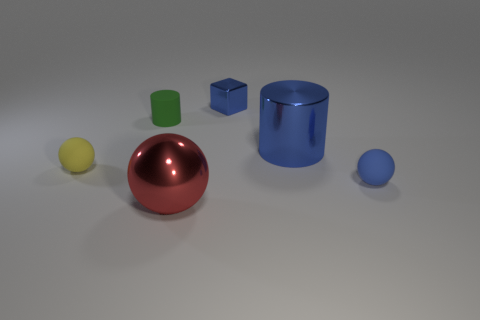Add 4 brown metal cylinders. How many objects exist? 10 Subtract all blocks. How many objects are left? 5 Add 5 small red rubber things. How many small red rubber things exist? 5 Subtract 0 cyan spheres. How many objects are left? 6 Subtract all small yellow objects. Subtract all large red shiny things. How many objects are left? 4 Add 5 tiny blue metallic objects. How many tiny blue metallic objects are left? 6 